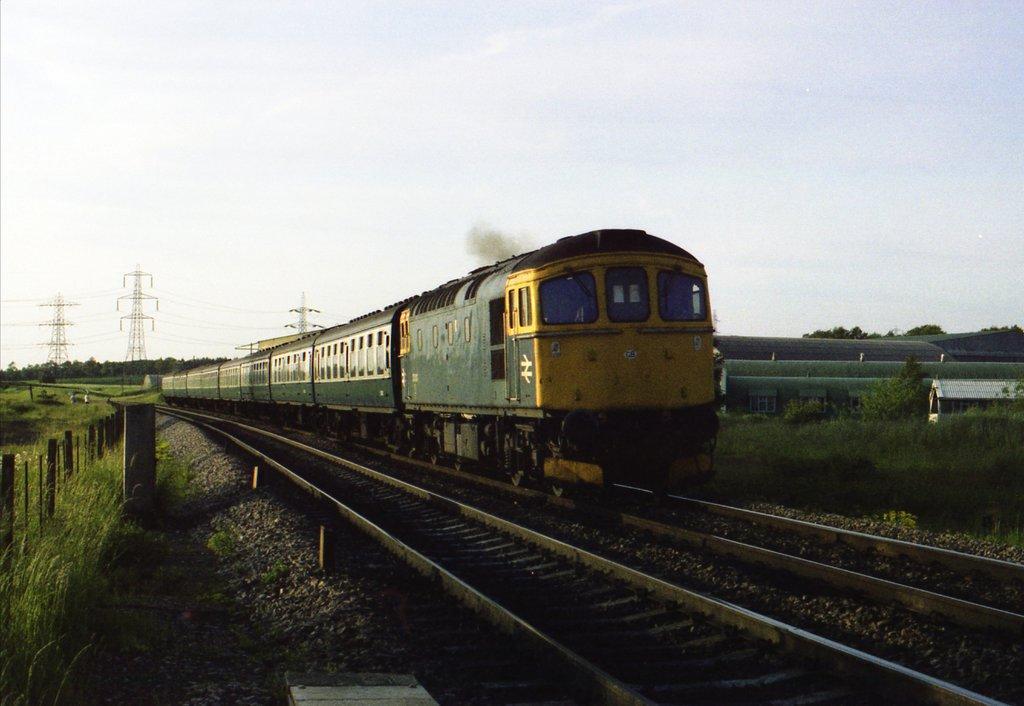Could you give a brief overview of what you see in this image? In this image there is a train on the railway track, Beside the train there is a fence. At the bottom there are stones. At the top there is the sky. In the background there are towers with the wires. On the left side there are small plants and grass. On the right side there is a small house in the grass. 